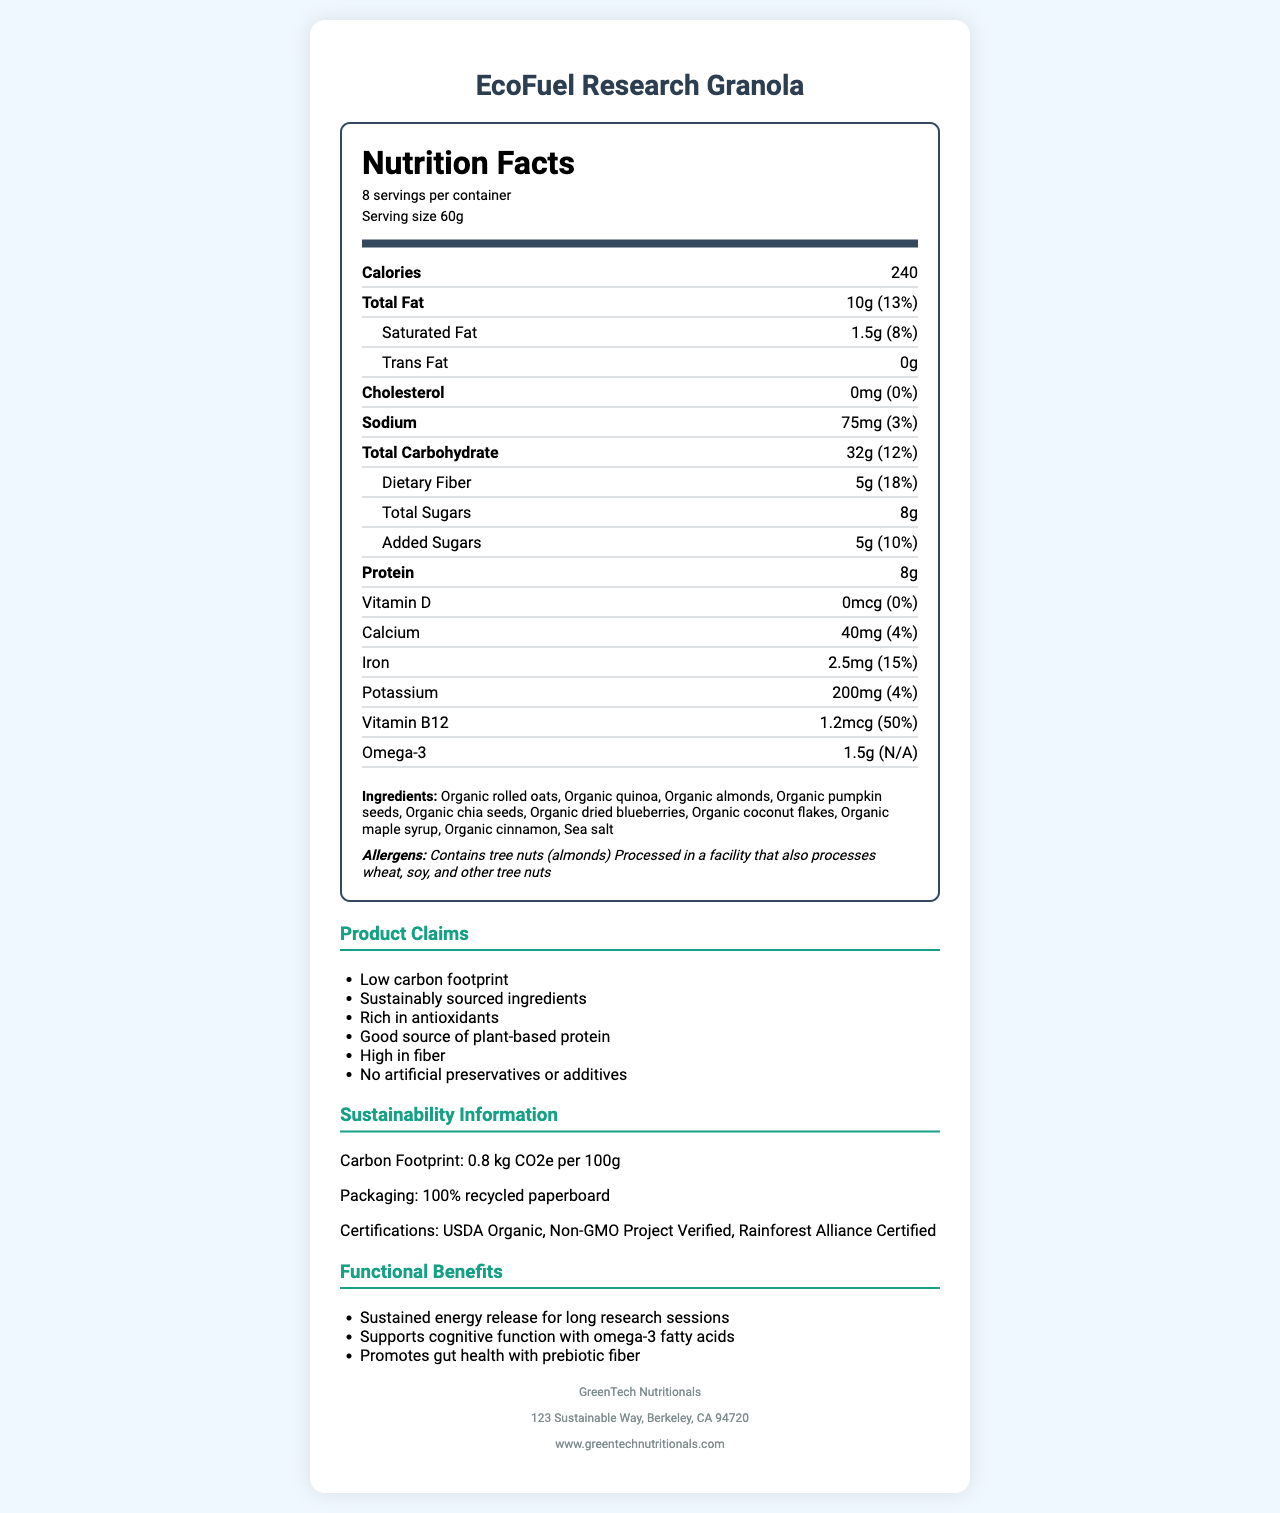what is the product name? The product name is explicitly stated at the top and title of the document as "EcoFuel Research Granola".
Answer: EcoFuel Research Granola how many servings are in the container? The number of servings per container is provided under the serving information section as "8 servings per container".
Answer: 8 what is the serving size? The serving size is specified in the serving information section as "Serving size 60g".
Answer: 60g how many calories are there per serving? The number of calories per serving is listed as "Calories 240" in the nutrition label.
Answer: 240 is there any trans fat in the product? The amount of trans fat is explicitly stated as "Trans Fat 0g", indicating there is no trans fat in the product.
Answer: No what ingredients are listed? The ingredients list is found below the nutrition information and explicitly lists all the ingredients.
Answer: Organic rolled oats, Organic quinoa, Organic almonds, Organic pumpkin seeds, Organic chia seeds, Organic dried blueberries, Organic coconut flakes, Organic maple syrup, Organic cinnamon, Sea salt how much is the daily value percentage of vitamin B12 per serving? The daily value percentage of vitamin B12 is listed as "Vitamin B12 1.2mcg (50%)".
Answer: 50% which certification is NOT mentioned on the document? A. USDA Organic B. Fair Trade Certified C. Non-GMO Project Verified D. Rainforest Alliance Certified The document mentions "USDA Organic", "Non-GMO Project Verified", and "Rainforest Alliance Certified" under the sustainability information but does not mention "Fair Trade Certified".
Answer: B. Fair Trade Certified what is the amount of dietary fiber per serving? The amount of dietary fiber per serving is noted as "Dietary Fiber 5g".
Answer: 5g what is the serving size of the product? A. 30g B. 40g C. 50g D. 60g The serving size is specifically given as "Serving size 60g".
Answer: D. 60g does the product contain any artificial preservatives? One of the product claims clearly states "No artificial preservatives or additives".
Answer: No summarize the main information provided in the document. The document comprehensively outlines nutritional values, ingredients, allergies, claims related to health and sustainability, packaging certifications, and functional benefits of the granola mix, giving a full picture of the product's attributes and intended use.
Answer: The document provides a detailed description of the "EcoFuel Research Granola," focusing on its nutritional content per 60g serving, including calories, macronutrients, vitamins, and minerals. It also covers ingredients, allergens, product claims, sustainability information, and functional benefits, as well as manufacturer details and storage instructions. who is the manufacturer of the product? The manufacturer's name is listed at the bottom of the document under manufacturer information as "GreenTech Nutritionals".
Answer: GreenTech Nutritionals what is the packaging material of the product? The packaging material is specified in the sustainability section, which mentions that the product uses "100% recycled paperboard".
Answer: 100% recycled paperboard does the product contain cholesterol? The nutrition label indicates "Cholesterol 0mg (0%)", meaning it is cholesterol-free.
Answer: No is this product suitable for someone allergic to almonds? The allergens section specifies that the product contains tree nuts (almonds), making it unsuitable for someone with an almond allergy.
Answer: No how much protein does one serving of the product contain? The protein content per serving is listed as "Protein 8g" in the nutrition label.
Answer: 8g what is the address of the manufacturer? The address of the manufacturer is given at the bottom of the document: "123 Sustainable Way, Berkeley, CA 94720".
Answer: 123 Sustainable Way, Berkeley, CA 94720 what are the claims made about the product? The product claims are listed after the nutrition and ingredients sections in the document.
Answer: Low carbon footprint, Sustainably sourced ingredients, Rich in antioxidants, Good source of plant-based protein, High in fiber, No artificial preservatives or additives what is the carbohydrate content per serving? The total carbohydrate content is given as "Total Carbohydrate 32g" in the nutrition label.
Answer: 32g how much omega-3 fatty acids are in a single serving? The omega-3 content per serving is listed as "Omega-3 1.5g".
Answer: 1.5g which vitamin is NOT included in this product? The document does not provide a comprehensive list of all vitamins; it only specifically mentions Vitamin D and Vitamin B12.
Answer: Cannot be determined what is the carbon footprint of this product? The carbon footprint is found in the sustainability information section as "Carbon Footprint: 0.8 kg CO2e per 100g".
Answer: 0.8 kg CO2e per 100g where should this product be stored after opening? The storage instructions at the bottom of the document specify: "Store in a cool, dry place. Reseal package after opening to maintain freshness".
Answer: Store in a cool, dry place. Reseal package after opening to maintain freshness. 